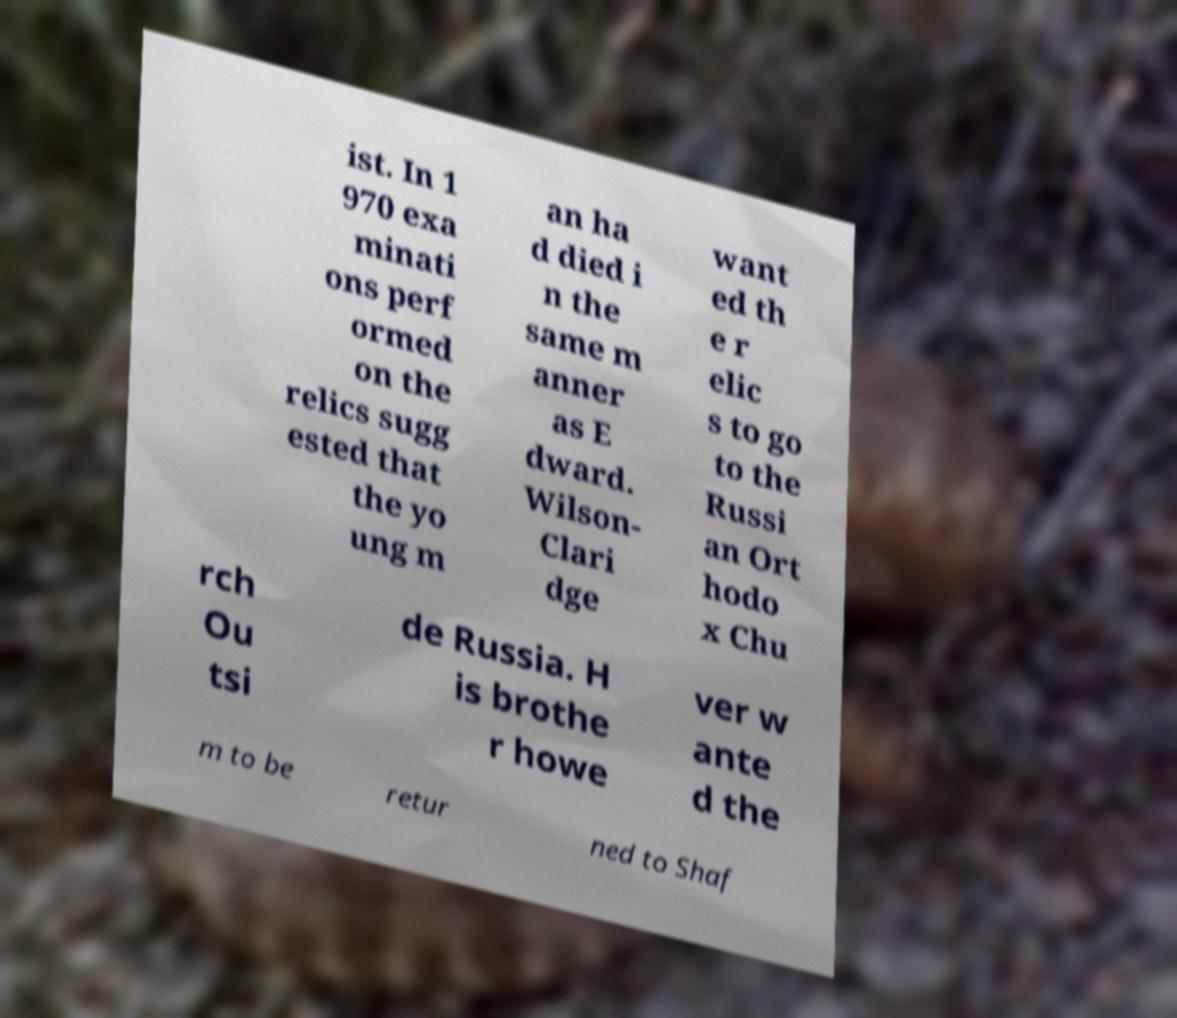Could you assist in decoding the text presented in this image and type it out clearly? ist. In 1 970 exa minati ons perf ormed on the relics sugg ested that the yo ung m an ha d died i n the same m anner as E dward. Wilson- Clari dge want ed th e r elic s to go to the Russi an Ort hodo x Chu rch Ou tsi de Russia. H is brothe r howe ver w ante d the m to be retur ned to Shaf 